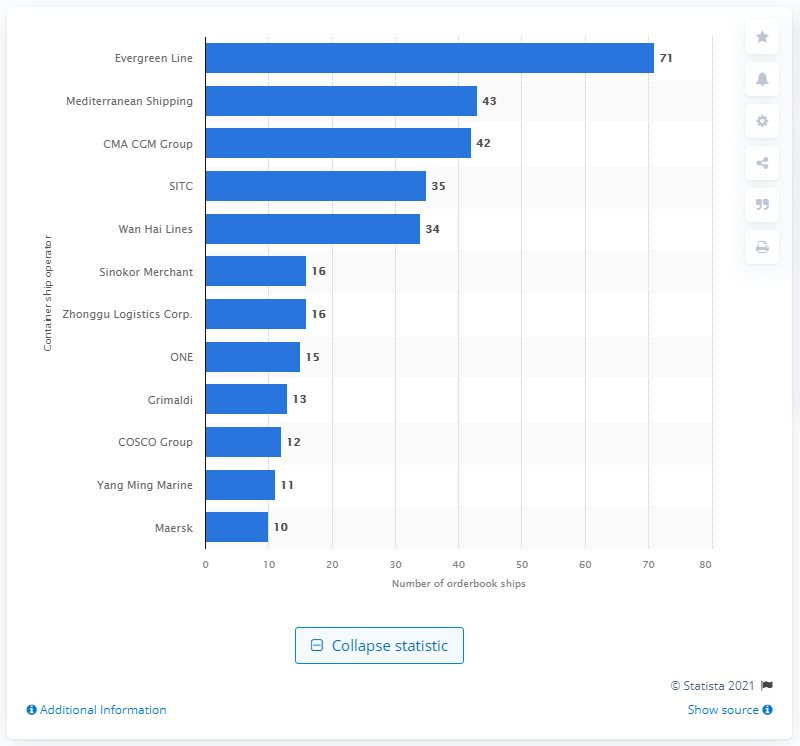How many ships were in CMA CGM Group's order book as of June 21, 2021?
 42 